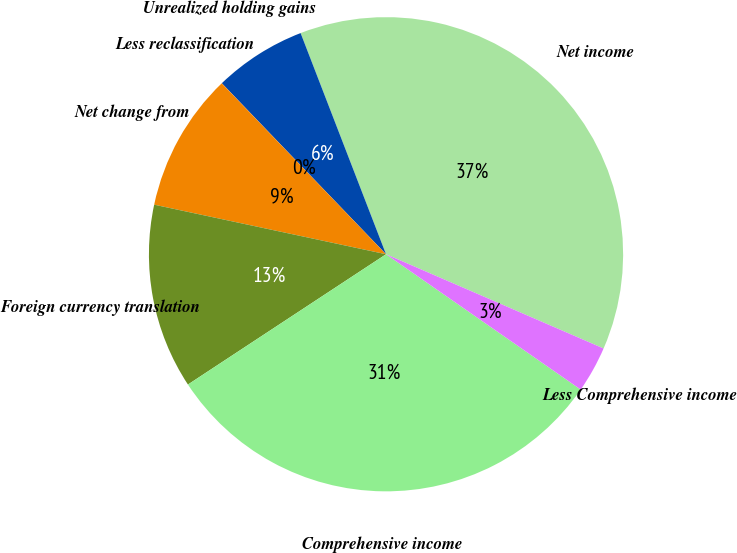Convert chart to OTSL. <chart><loc_0><loc_0><loc_500><loc_500><pie_chart><fcel>Net income<fcel>Unrealized holding gains<fcel>Less reclassification<fcel>Net change from<fcel>Foreign currency translation<fcel>Comprehensive income<fcel>Less Comprehensive income<nl><fcel>37.37%<fcel>6.31%<fcel>0.01%<fcel>9.46%<fcel>12.61%<fcel>31.07%<fcel>3.16%<nl></chart> 